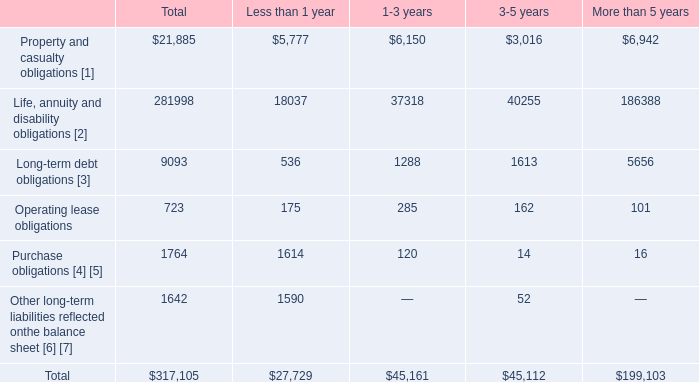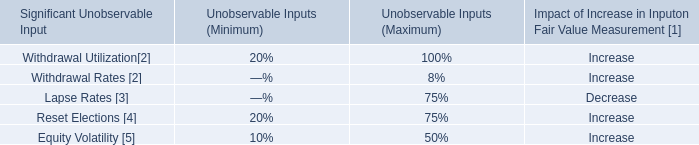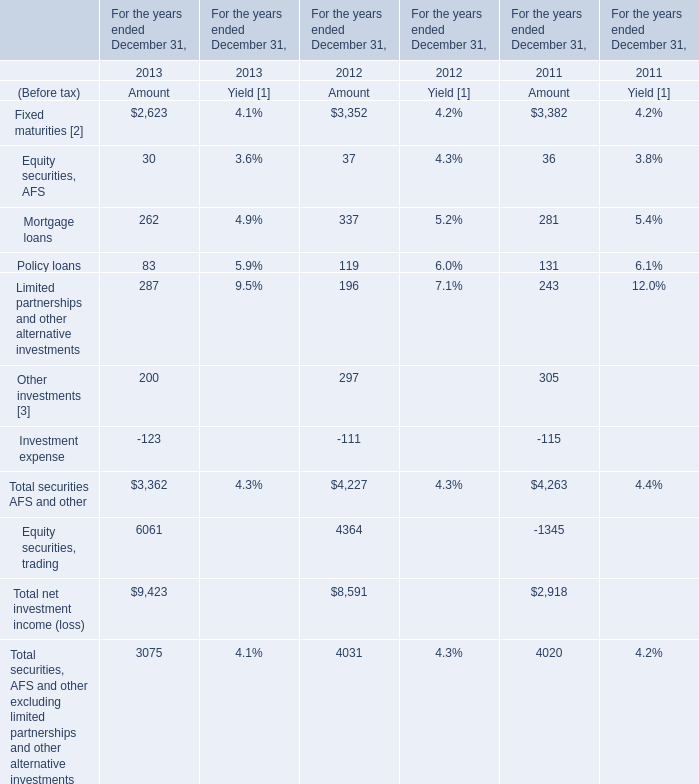What was the total amount of elements greater than 2000 in 2013? 
Computations: ((2623 + 6061) + 3075)
Answer: 11759.0. 